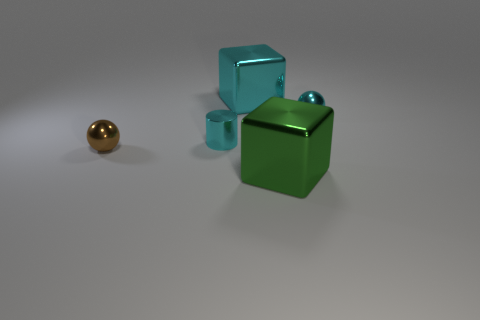Is there another small brown object that has the same shape as the tiny brown thing?
Offer a terse response. No. Does the cylinder have the same material as the thing that is in front of the small brown object?
Your answer should be compact. Yes. What color is the metal cylinder?
Your answer should be very brief. Cyan. What number of large metal blocks are in front of the metal object that is to the right of the big metallic block in front of the brown thing?
Ensure brevity in your answer.  1. There is a big cyan thing; are there any small cyan cylinders right of it?
Offer a terse response. No. How many cyan spheres are the same material as the cyan cylinder?
Your response must be concise. 1. What number of things are tiny cyan shiny spheres or large blocks?
Ensure brevity in your answer.  3. Is there a cyan shiny cylinder?
Your answer should be compact. Yes. Are there fewer green metal objects on the right side of the cyan metal ball than large gray things?
Your answer should be very brief. No. There is a cylinder that is the same size as the brown thing; what is it made of?
Provide a succinct answer. Metal. 